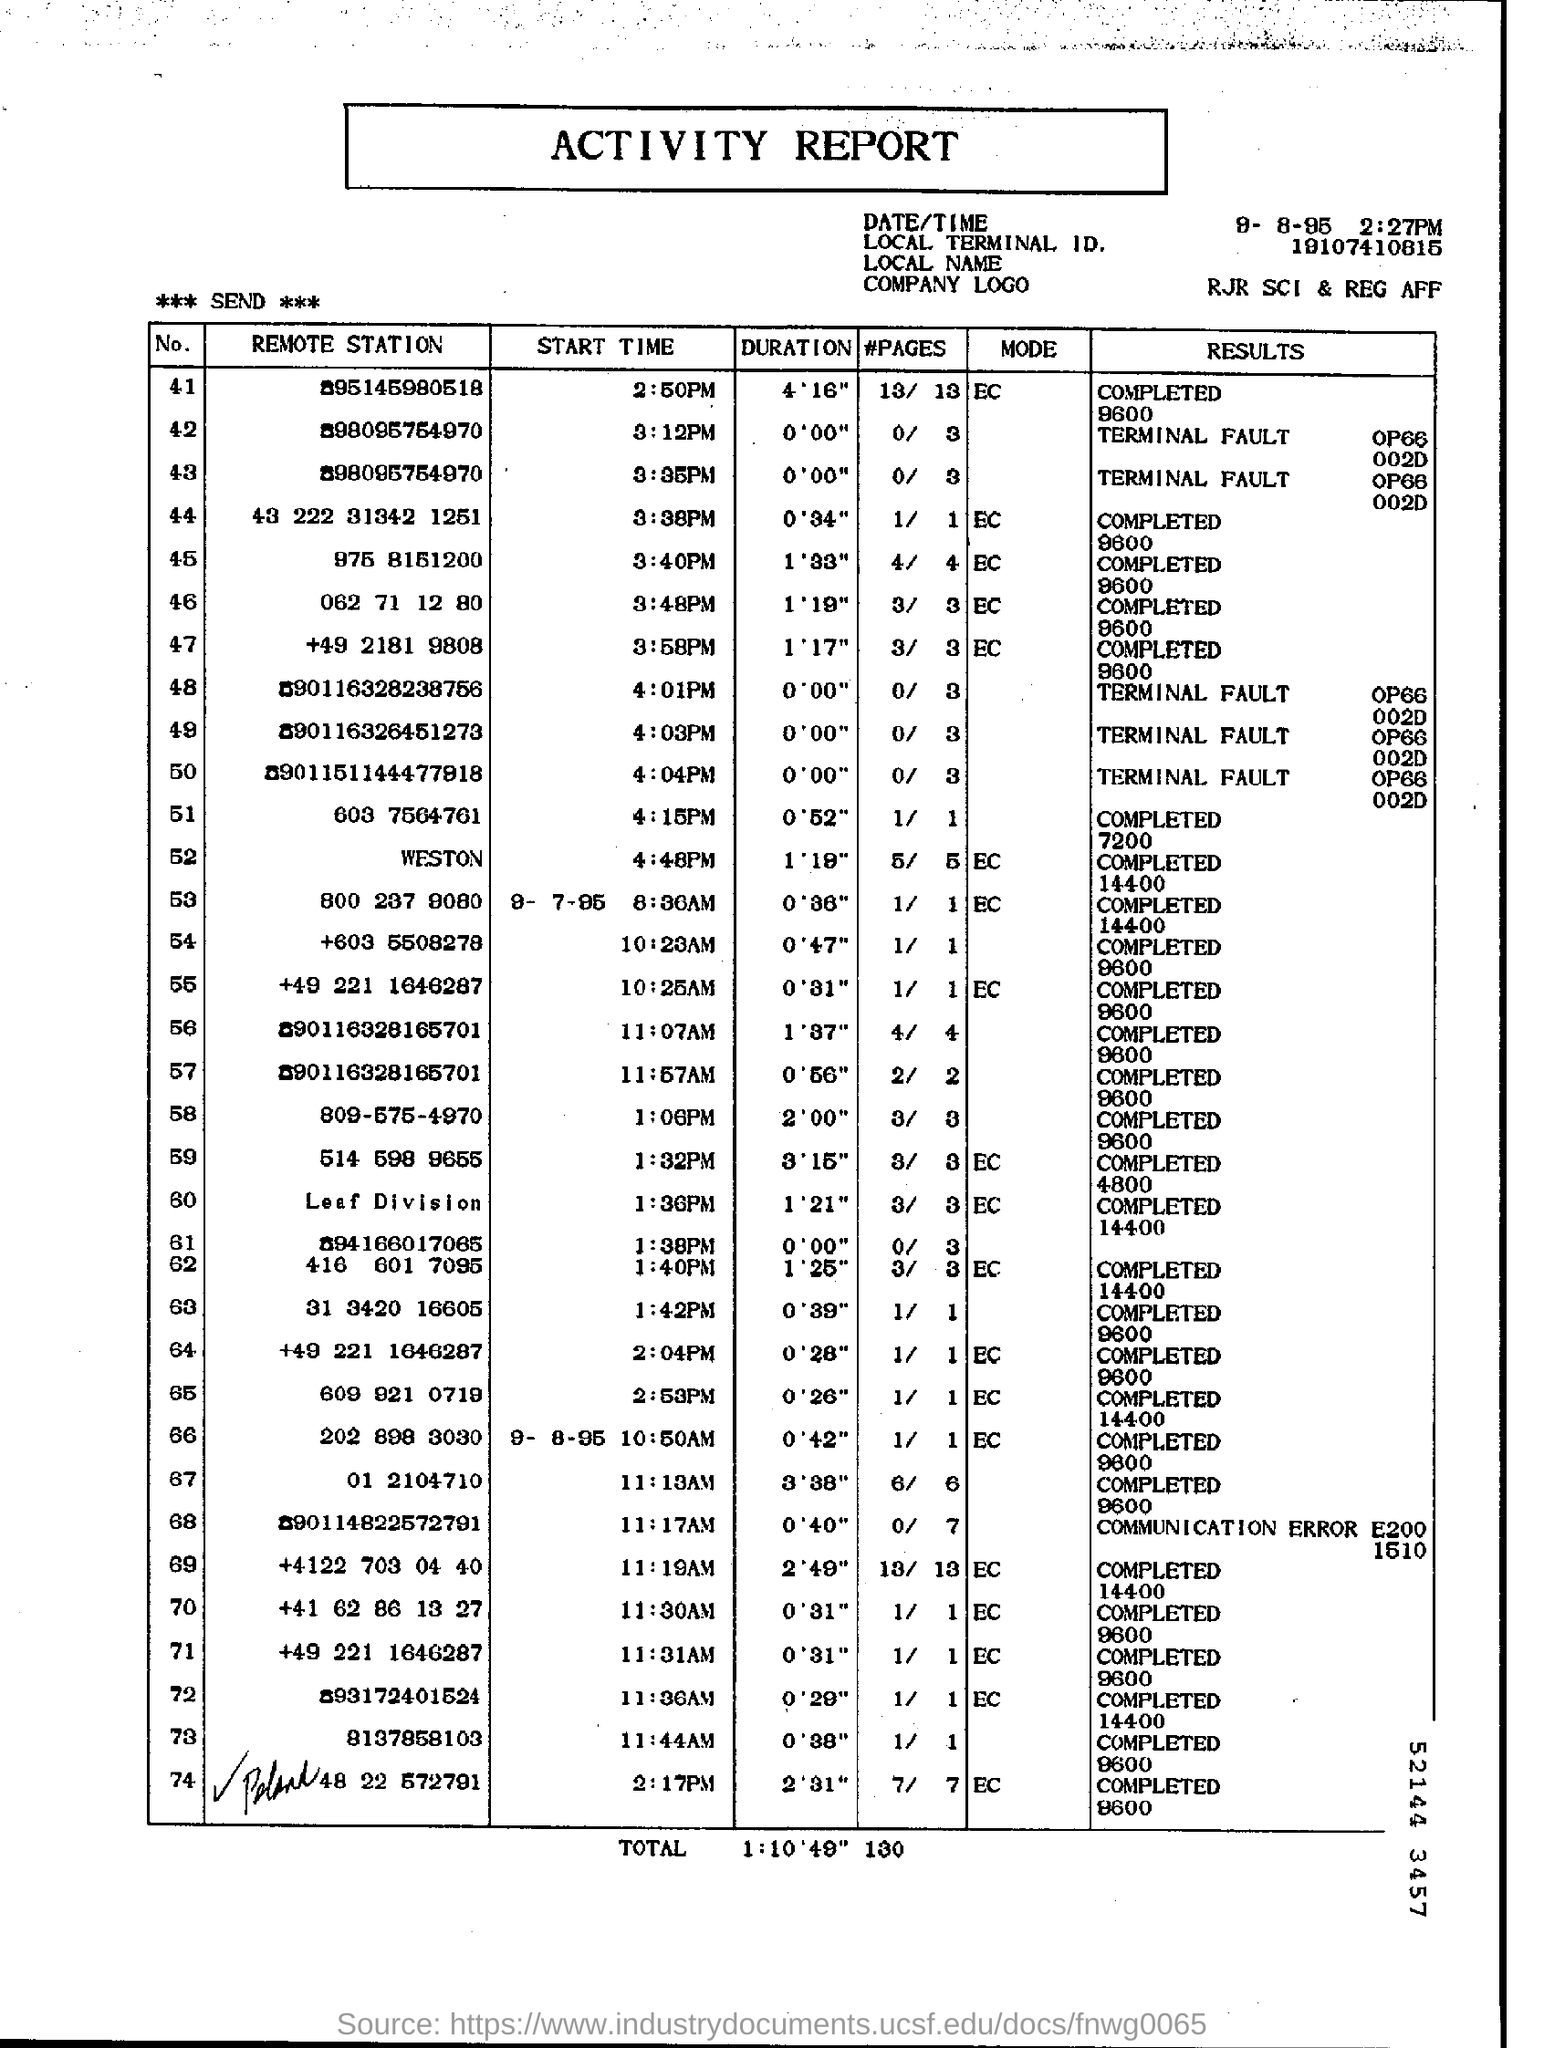Mention a couple of crucial points in this snapshot. The result for the remote station number "062 71 12 80" was completed at a rate of 9600. The duration for the remote station number "062 71 12 80" is 1 minute and 19 seconds. The "Start Time" for the "Remote station" identified as "062 71 12 80" is 3:48 pm. The duration for the remote station number 975 8151200 is 1 minute and 33 seconds. The Local Terminal ID is 19107410815. 